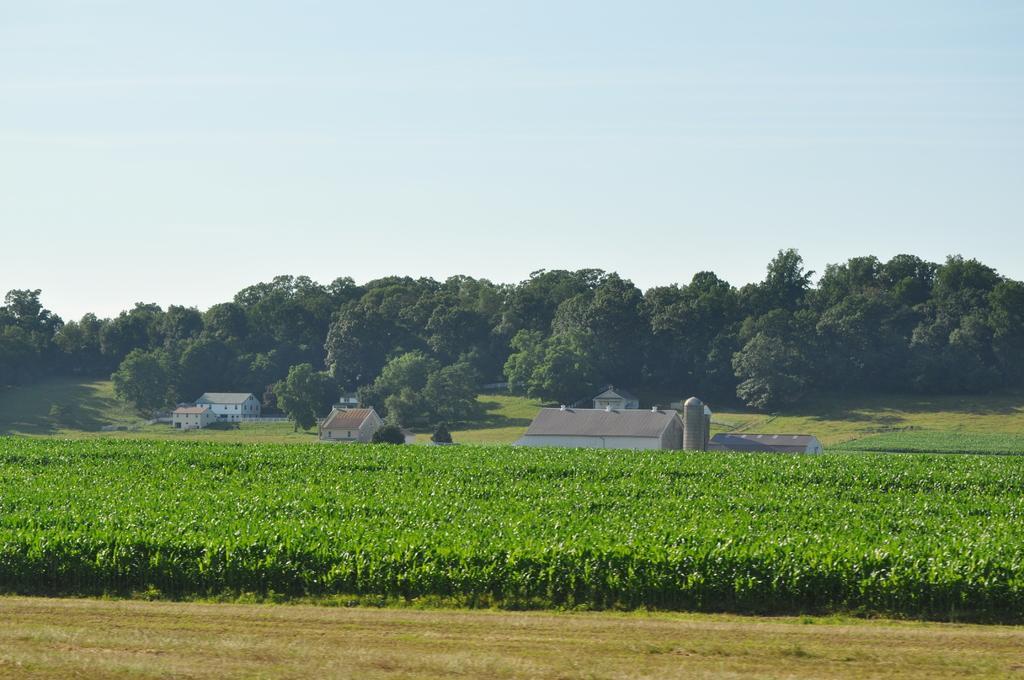Can you describe this image briefly? In this image, we can see plants and grass. Background we can see trees, houses, containers and sky. 